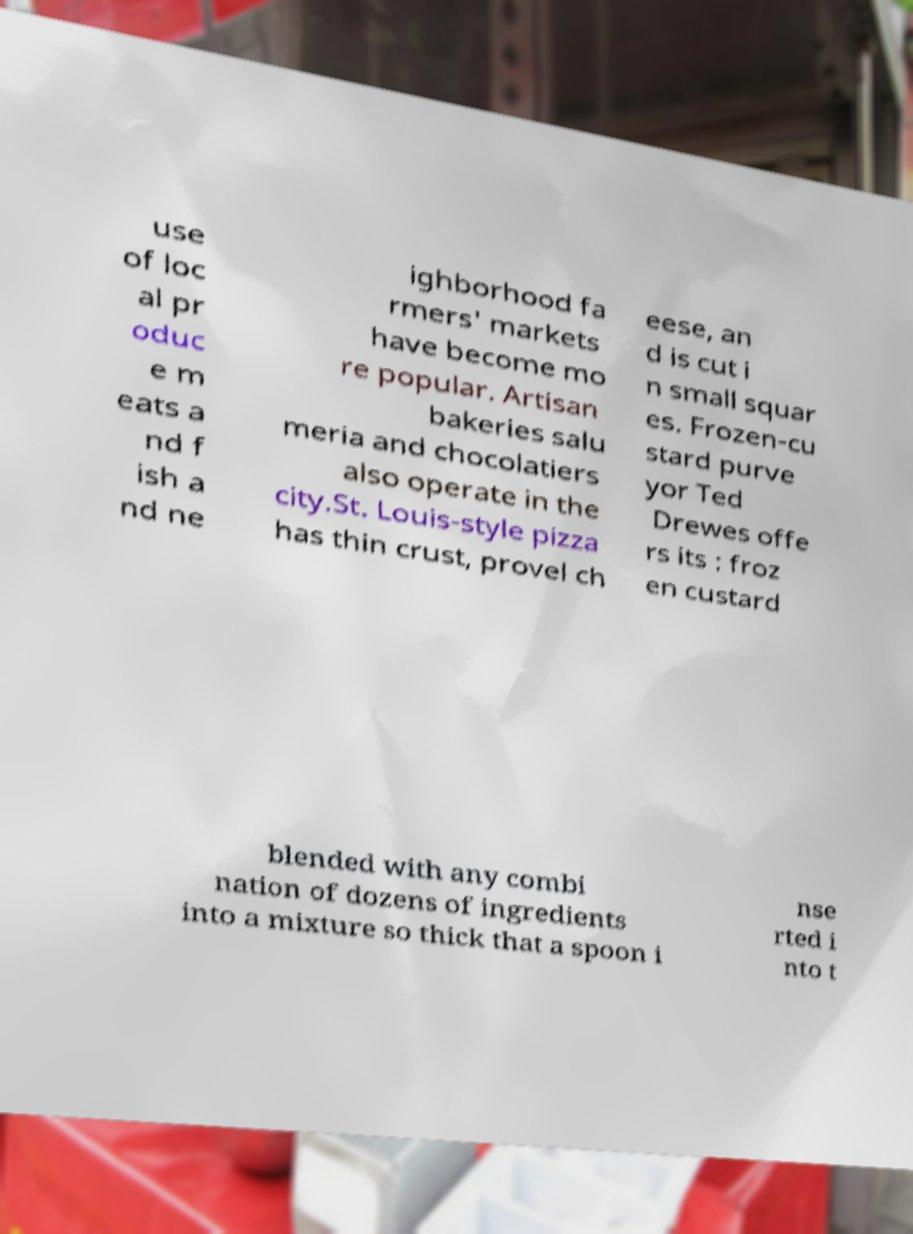For documentation purposes, I need the text within this image transcribed. Could you provide that? use of loc al pr oduc e m eats a nd f ish a nd ne ighborhood fa rmers' markets have become mo re popular. Artisan bakeries salu meria and chocolatiers also operate in the city.St. Louis-style pizza has thin crust, provel ch eese, an d is cut i n small squar es. Frozen-cu stard purve yor Ted Drewes offe rs its : froz en custard blended with any combi nation of dozens of ingredients into a mixture so thick that a spoon i nse rted i nto t 